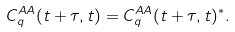Convert formula to latex. <formula><loc_0><loc_0><loc_500><loc_500>C _ { q } ^ { A A } ( t + \tau , t ) = C _ { q } ^ { A A } ( t + \tau , t ) ^ { * } .</formula> 